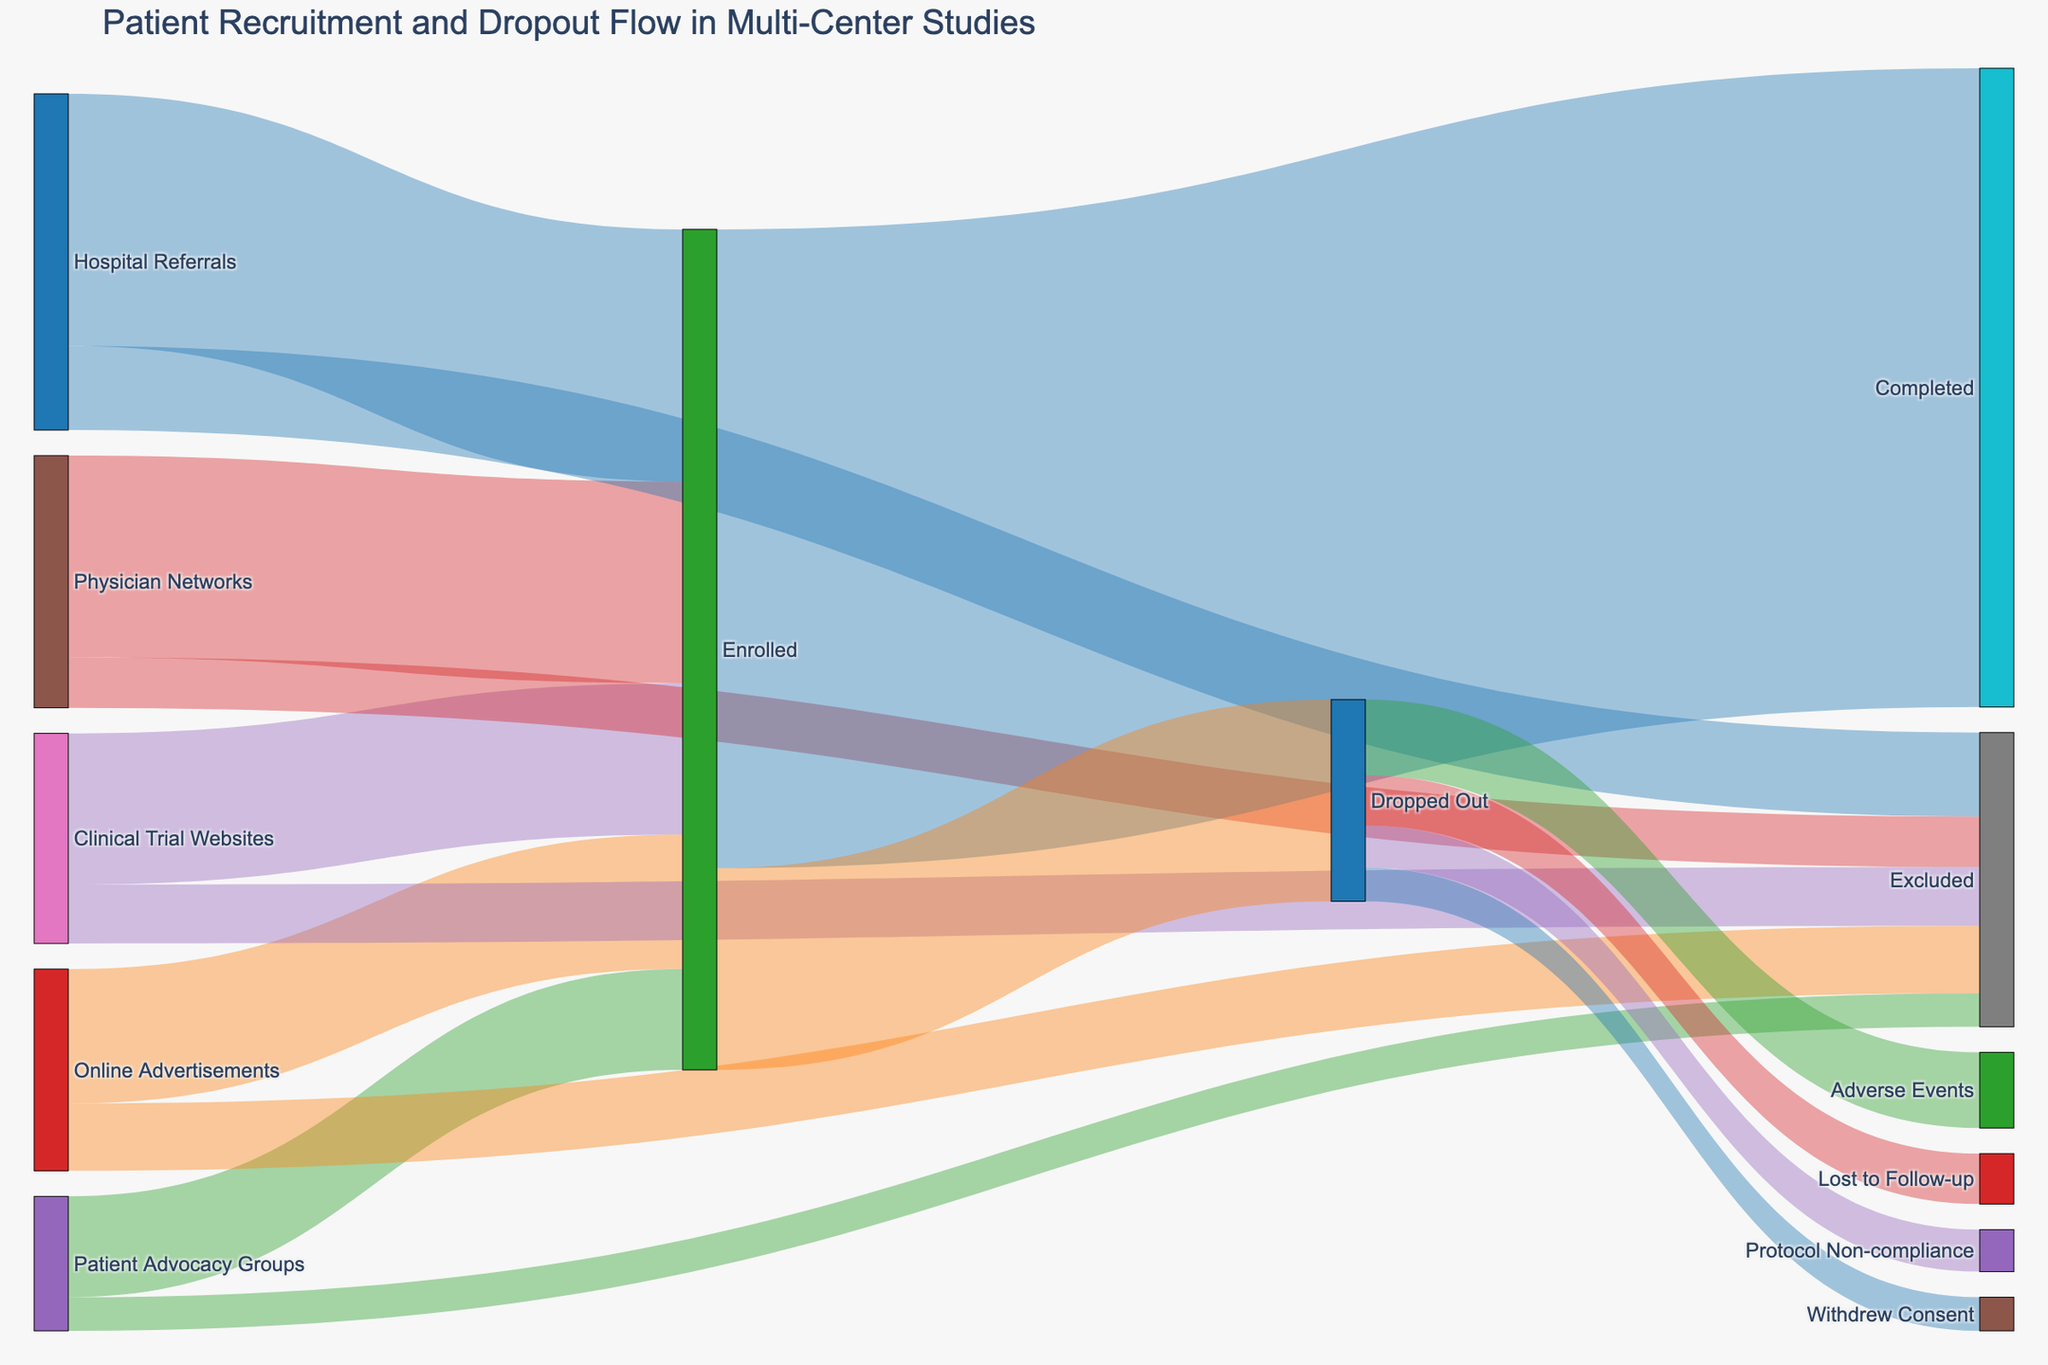How many patients were enrolled from hospital referrals? Look at the flow from "Hospital Referrals" to "Enrolled". The figure shows 150 patients.
Answer: 150 Which recruitment source contributed the least number of patients to the enrolled group? Compare the values from all sources (Hospital Referrals, Online Advertisements, Patient Advocacy Groups, Physician Networks, Clinical Trial Websites) to "Enrolled". Patient Advocacy Groups has the smallest value, with 60 patients.
Answer: Patient Advocacy Groups What is the total number of patients who were excluded during screening? Add up the values going to "Excluded": 50 (Hospital Referrals) + 40 (Online Advertisements) + 20 (Patient Advocacy Groups) + 30 (Physician Networks) + 35 (Clinical Trial Websites) = 175.
Answer: 175 How many patients completed the study? Follow the flow from "Enrolled" to "Completed". The figure shows 380 patients.
Answer: 380 Out of those who dropped out, what proportion left due to adverse events? Determine the total number of patients who dropped out (120) and then those who left due to adverse events (45). The proportion is 45/120, which simplifies to 0.375 or 37.5%.
Answer: 37.5% Compare the number of patients who dropped out due to lost to follow-up with those due to protocol non-compliance. Which is higher? Look at the flow from "Dropped Out" to "Lost to Follow-up" (30) and compare with "Protocol Non-compliance" (25). 30 is greater than 25.
Answer: Lost to follow-up What is the largest single source of recruited patients overall? Look at the total number of patients going from each source to "Enrolled" and "Excluded": Hospital Referrals has 150 + 50 = 200 patients, the highest.
Answer: Hospital Referrals Calculate the dropout rate among enrolled patients. Divide the number of patients who dropped out (120) by the total number of enrolled patients (150+80+60+120+90 = 500). The dropout rate is 120/500 = 0.24 or 24%.
Answer: 24% Which specific reason for dropouts had the second-highest number of patients? Among reasons ("Adverse Events": 45, "Lost to Follow-up": 30, "Protocol Non-compliance": 25, "Withdrew Consent": 20), the second highest is "Lost to Follow-up" with 30 patients.
Answer: Lost to Follow-up How many more patients were recruited via physician networks compared to patient advocacy groups? Subtract the number of patients from "Patient Advocacy Groups" (60) from "Physician Networks" (120). 120 - 60 = 60.
Answer: 60 